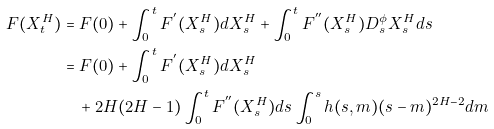<formula> <loc_0><loc_0><loc_500><loc_500>F ( X _ { t } ^ { H } ) & = F ( 0 ) + \int _ { 0 } ^ { t } F ^ { ^ { \prime } } ( X _ { s } ^ { H } ) d X _ { s } ^ { H } + \int _ { 0 } ^ { t } F ^ { ^ { \prime \prime } } ( X _ { s } ^ { H } ) D ^ { \phi } _ { s } X _ { s } ^ { H } d s \\ & = F ( 0 ) + \int _ { 0 } ^ { t } F ^ { ^ { \prime } } ( X _ { s } ^ { H } ) d X _ { s } ^ { H } \\ & \quad + 2 { H } ( 2 H - 1 ) \int _ { 0 } ^ { t } F ^ { ^ { \prime \prime } } ( X _ { s } ^ { H } ) d s \int _ { 0 } ^ { s } h ( s , m ) ( s - m ) ^ { 2 H - 2 } d m</formula> 